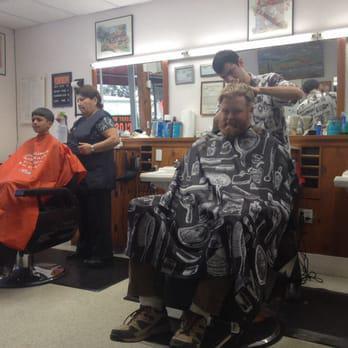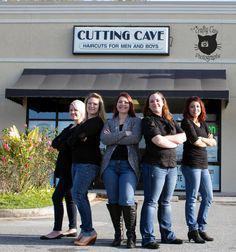The first image is the image on the left, the second image is the image on the right. For the images displayed, is the sentence "In one of the images, people are outside the storefront under the sign." factually correct? Answer yes or no. Yes. The first image is the image on the left, the second image is the image on the right. For the images displayed, is the sentence "One of the images shows a group of exactly women with arms folded." factually correct? Answer yes or no. Yes. 